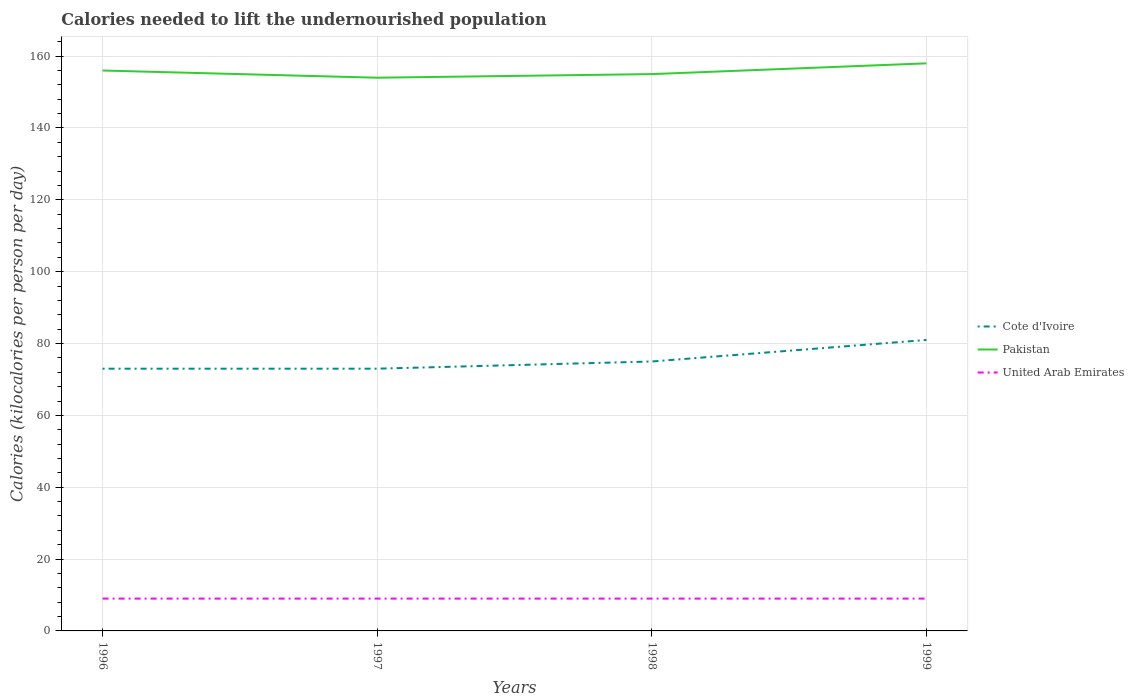Across all years, what is the maximum total calories needed to lift the undernourished population in Cote d'Ivoire?
Provide a short and direct response. 73. In which year was the total calories needed to lift the undernourished population in United Arab Emirates maximum?
Provide a succinct answer. 1996. What is the total total calories needed to lift the undernourished population in Cote d'Ivoire in the graph?
Make the answer very short. -8. What is the difference between the highest and the second highest total calories needed to lift the undernourished population in Pakistan?
Give a very brief answer. 4. Is the total calories needed to lift the undernourished population in United Arab Emirates strictly greater than the total calories needed to lift the undernourished population in Pakistan over the years?
Provide a short and direct response. Yes. What is the difference between two consecutive major ticks on the Y-axis?
Your answer should be very brief. 20. Are the values on the major ticks of Y-axis written in scientific E-notation?
Keep it short and to the point. No. Does the graph contain grids?
Ensure brevity in your answer.  Yes. How are the legend labels stacked?
Provide a short and direct response. Vertical. What is the title of the graph?
Offer a terse response. Calories needed to lift the undernourished population. What is the label or title of the X-axis?
Offer a terse response. Years. What is the label or title of the Y-axis?
Offer a very short reply. Calories (kilocalories per person per day). What is the Calories (kilocalories per person per day) in Cote d'Ivoire in 1996?
Offer a very short reply. 73. What is the Calories (kilocalories per person per day) in Pakistan in 1996?
Keep it short and to the point. 156. What is the Calories (kilocalories per person per day) in United Arab Emirates in 1996?
Your answer should be compact. 9. What is the Calories (kilocalories per person per day) of Pakistan in 1997?
Make the answer very short. 154. What is the Calories (kilocalories per person per day) of United Arab Emirates in 1997?
Keep it short and to the point. 9. What is the Calories (kilocalories per person per day) in Pakistan in 1998?
Make the answer very short. 155. What is the Calories (kilocalories per person per day) of Cote d'Ivoire in 1999?
Keep it short and to the point. 81. What is the Calories (kilocalories per person per day) of Pakistan in 1999?
Give a very brief answer. 158. Across all years, what is the maximum Calories (kilocalories per person per day) in Pakistan?
Offer a very short reply. 158. Across all years, what is the maximum Calories (kilocalories per person per day) of United Arab Emirates?
Offer a very short reply. 9. Across all years, what is the minimum Calories (kilocalories per person per day) in Cote d'Ivoire?
Offer a terse response. 73. Across all years, what is the minimum Calories (kilocalories per person per day) in Pakistan?
Offer a very short reply. 154. Across all years, what is the minimum Calories (kilocalories per person per day) in United Arab Emirates?
Make the answer very short. 9. What is the total Calories (kilocalories per person per day) in Cote d'Ivoire in the graph?
Provide a succinct answer. 302. What is the total Calories (kilocalories per person per day) of Pakistan in the graph?
Ensure brevity in your answer.  623. What is the total Calories (kilocalories per person per day) of United Arab Emirates in the graph?
Offer a very short reply. 36. What is the difference between the Calories (kilocalories per person per day) of Cote d'Ivoire in 1996 and that in 1997?
Make the answer very short. 0. What is the difference between the Calories (kilocalories per person per day) in United Arab Emirates in 1996 and that in 1997?
Give a very brief answer. 0. What is the difference between the Calories (kilocalories per person per day) of United Arab Emirates in 1996 and that in 1998?
Provide a short and direct response. 0. What is the difference between the Calories (kilocalories per person per day) in Cote d'Ivoire in 1996 and that in 1999?
Offer a terse response. -8. What is the difference between the Calories (kilocalories per person per day) of Pakistan in 1996 and that in 1999?
Keep it short and to the point. -2. What is the difference between the Calories (kilocalories per person per day) in Cote d'Ivoire in 1997 and that in 1998?
Keep it short and to the point. -2. What is the difference between the Calories (kilocalories per person per day) of Pakistan in 1997 and that in 1998?
Your answer should be very brief. -1. What is the difference between the Calories (kilocalories per person per day) of United Arab Emirates in 1997 and that in 1998?
Keep it short and to the point. 0. What is the difference between the Calories (kilocalories per person per day) in Cote d'Ivoire in 1997 and that in 1999?
Offer a terse response. -8. What is the difference between the Calories (kilocalories per person per day) of United Arab Emirates in 1997 and that in 1999?
Ensure brevity in your answer.  0. What is the difference between the Calories (kilocalories per person per day) of Cote d'Ivoire in 1996 and the Calories (kilocalories per person per day) of Pakistan in 1997?
Provide a short and direct response. -81. What is the difference between the Calories (kilocalories per person per day) of Pakistan in 1996 and the Calories (kilocalories per person per day) of United Arab Emirates in 1997?
Your answer should be compact. 147. What is the difference between the Calories (kilocalories per person per day) in Cote d'Ivoire in 1996 and the Calories (kilocalories per person per day) in Pakistan in 1998?
Provide a succinct answer. -82. What is the difference between the Calories (kilocalories per person per day) in Pakistan in 1996 and the Calories (kilocalories per person per day) in United Arab Emirates in 1998?
Offer a terse response. 147. What is the difference between the Calories (kilocalories per person per day) of Cote d'Ivoire in 1996 and the Calories (kilocalories per person per day) of Pakistan in 1999?
Give a very brief answer. -85. What is the difference between the Calories (kilocalories per person per day) of Pakistan in 1996 and the Calories (kilocalories per person per day) of United Arab Emirates in 1999?
Offer a very short reply. 147. What is the difference between the Calories (kilocalories per person per day) of Cote d'Ivoire in 1997 and the Calories (kilocalories per person per day) of Pakistan in 1998?
Give a very brief answer. -82. What is the difference between the Calories (kilocalories per person per day) in Pakistan in 1997 and the Calories (kilocalories per person per day) in United Arab Emirates in 1998?
Make the answer very short. 145. What is the difference between the Calories (kilocalories per person per day) of Cote d'Ivoire in 1997 and the Calories (kilocalories per person per day) of Pakistan in 1999?
Offer a very short reply. -85. What is the difference between the Calories (kilocalories per person per day) of Pakistan in 1997 and the Calories (kilocalories per person per day) of United Arab Emirates in 1999?
Make the answer very short. 145. What is the difference between the Calories (kilocalories per person per day) of Cote d'Ivoire in 1998 and the Calories (kilocalories per person per day) of Pakistan in 1999?
Make the answer very short. -83. What is the difference between the Calories (kilocalories per person per day) in Pakistan in 1998 and the Calories (kilocalories per person per day) in United Arab Emirates in 1999?
Provide a succinct answer. 146. What is the average Calories (kilocalories per person per day) of Cote d'Ivoire per year?
Provide a succinct answer. 75.5. What is the average Calories (kilocalories per person per day) in Pakistan per year?
Your answer should be very brief. 155.75. What is the average Calories (kilocalories per person per day) of United Arab Emirates per year?
Provide a short and direct response. 9. In the year 1996, what is the difference between the Calories (kilocalories per person per day) in Cote d'Ivoire and Calories (kilocalories per person per day) in Pakistan?
Provide a succinct answer. -83. In the year 1996, what is the difference between the Calories (kilocalories per person per day) in Cote d'Ivoire and Calories (kilocalories per person per day) in United Arab Emirates?
Ensure brevity in your answer.  64. In the year 1996, what is the difference between the Calories (kilocalories per person per day) of Pakistan and Calories (kilocalories per person per day) of United Arab Emirates?
Ensure brevity in your answer.  147. In the year 1997, what is the difference between the Calories (kilocalories per person per day) of Cote d'Ivoire and Calories (kilocalories per person per day) of Pakistan?
Make the answer very short. -81. In the year 1997, what is the difference between the Calories (kilocalories per person per day) of Pakistan and Calories (kilocalories per person per day) of United Arab Emirates?
Ensure brevity in your answer.  145. In the year 1998, what is the difference between the Calories (kilocalories per person per day) of Cote d'Ivoire and Calories (kilocalories per person per day) of Pakistan?
Make the answer very short. -80. In the year 1998, what is the difference between the Calories (kilocalories per person per day) of Pakistan and Calories (kilocalories per person per day) of United Arab Emirates?
Offer a very short reply. 146. In the year 1999, what is the difference between the Calories (kilocalories per person per day) of Cote d'Ivoire and Calories (kilocalories per person per day) of Pakistan?
Make the answer very short. -77. In the year 1999, what is the difference between the Calories (kilocalories per person per day) in Cote d'Ivoire and Calories (kilocalories per person per day) in United Arab Emirates?
Keep it short and to the point. 72. In the year 1999, what is the difference between the Calories (kilocalories per person per day) in Pakistan and Calories (kilocalories per person per day) in United Arab Emirates?
Your answer should be compact. 149. What is the ratio of the Calories (kilocalories per person per day) of Cote d'Ivoire in 1996 to that in 1997?
Your answer should be compact. 1. What is the ratio of the Calories (kilocalories per person per day) of Cote d'Ivoire in 1996 to that in 1998?
Keep it short and to the point. 0.97. What is the ratio of the Calories (kilocalories per person per day) of United Arab Emirates in 1996 to that in 1998?
Your answer should be compact. 1. What is the ratio of the Calories (kilocalories per person per day) of Cote d'Ivoire in 1996 to that in 1999?
Your response must be concise. 0.9. What is the ratio of the Calories (kilocalories per person per day) in Pakistan in 1996 to that in 1999?
Give a very brief answer. 0.99. What is the ratio of the Calories (kilocalories per person per day) in United Arab Emirates in 1996 to that in 1999?
Give a very brief answer. 1. What is the ratio of the Calories (kilocalories per person per day) of Cote d'Ivoire in 1997 to that in 1998?
Provide a short and direct response. 0.97. What is the ratio of the Calories (kilocalories per person per day) of United Arab Emirates in 1997 to that in 1998?
Make the answer very short. 1. What is the ratio of the Calories (kilocalories per person per day) in Cote d'Ivoire in 1997 to that in 1999?
Give a very brief answer. 0.9. What is the ratio of the Calories (kilocalories per person per day) in Pakistan in 1997 to that in 1999?
Your answer should be very brief. 0.97. What is the ratio of the Calories (kilocalories per person per day) in United Arab Emirates in 1997 to that in 1999?
Ensure brevity in your answer.  1. What is the ratio of the Calories (kilocalories per person per day) of Cote d'Ivoire in 1998 to that in 1999?
Give a very brief answer. 0.93. What is the ratio of the Calories (kilocalories per person per day) in Pakistan in 1998 to that in 1999?
Offer a terse response. 0.98. What is the ratio of the Calories (kilocalories per person per day) in United Arab Emirates in 1998 to that in 1999?
Give a very brief answer. 1. What is the difference between the highest and the second highest Calories (kilocalories per person per day) in Cote d'Ivoire?
Offer a terse response. 6. What is the difference between the highest and the second highest Calories (kilocalories per person per day) in Pakistan?
Provide a succinct answer. 2. What is the difference between the highest and the lowest Calories (kilocalories per person per day) of Pakistan?
Provide a succinct answer. 4. 